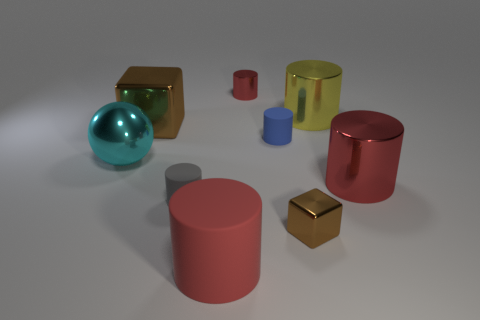Subtract all small blue cylinders. How many cylinders are left? 5 Subtract all red cylinders. How many cylinders are left? 3 Subtract all spheres. How many objects are left? 8 Subtract all yellow cubes. How many blue spheres are left? 0 Subtract all cyan metal spheres. Subtract all cyan metal objects. How many objects are left? 7 Add 3 big yellow things. How many big yellow things are left? 4 Add 6 tiny gray matte objects. How many tiny gray matte objects exist? 7 Subtract 1 red cylinders. How many objects are left? 8 Subtract 4 cylinders. How many cylinders are left? 2 Subtract all brown cylinders. Subtract all green balls. How many cylinders are left? 6 